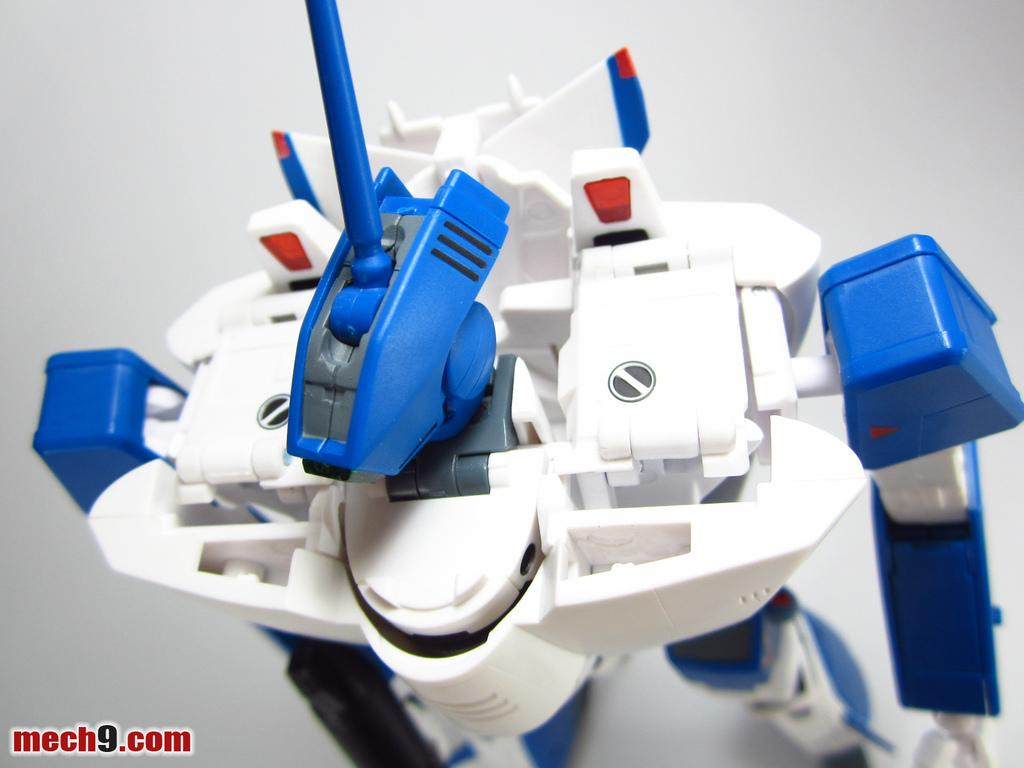What type of toy is present in the image? There is a robot toy in the image. Can you describe the toy in more detail? The robot toy is likely made of plastic and has various mechanical parts. What might the robot toy be able to do? The robot toy might be able to move, make sounds, or light up, depending on its design and features. How much credit does the robot toy have in the image? There is no reference to credit or financial transactions in the image, as it features a robot toy. 